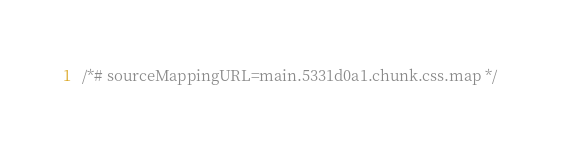Convert code to text. <code><loc_0><loc_0><loc_500><loc_500><_CSS_>/*# sourceMappingURL=main.5331d0a1.chunk.css.map */</code> 